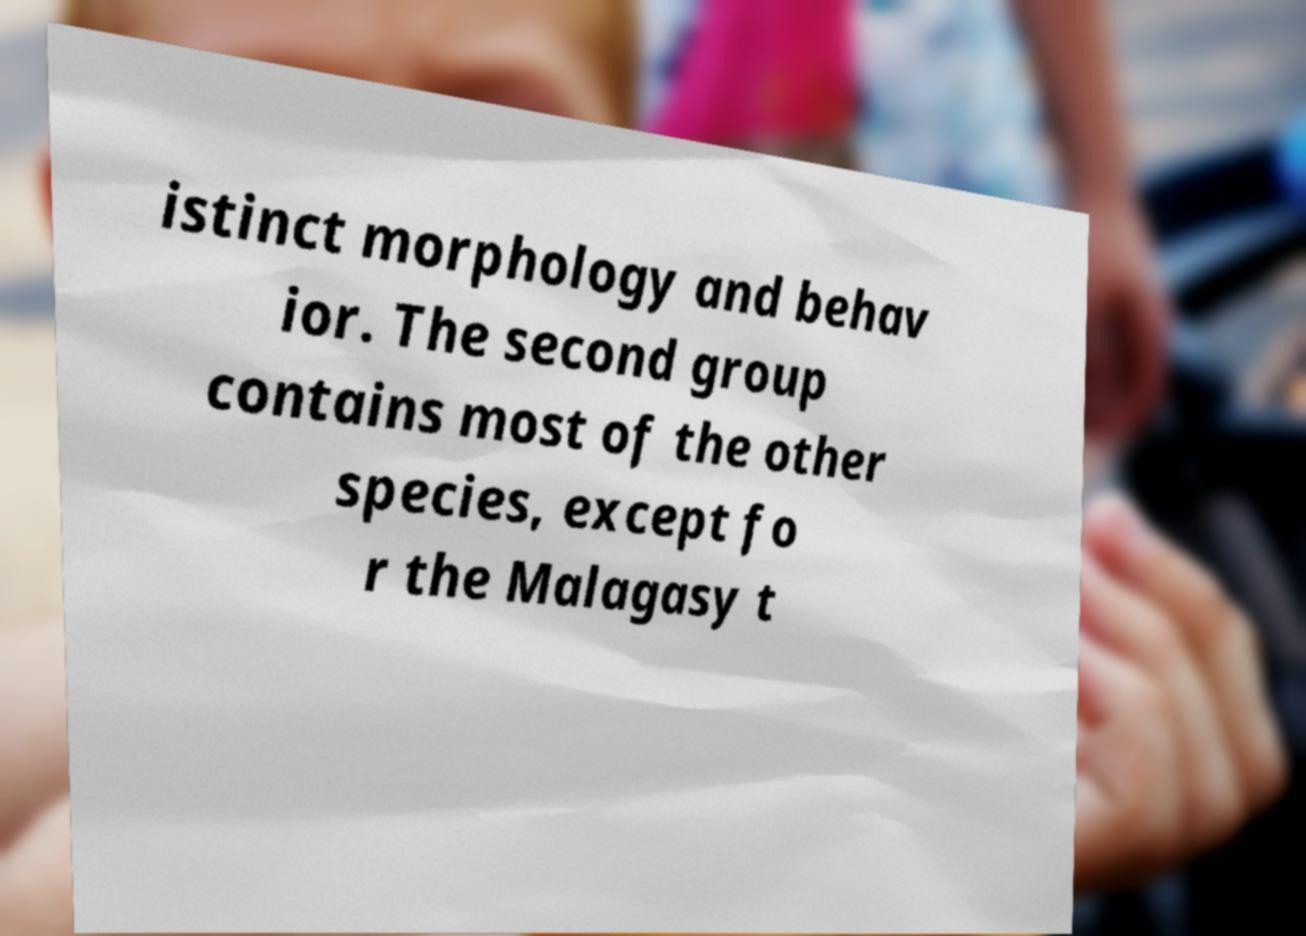For documentation purposes, I need the text within this image transcribed. Could you provide that? istinct morphology and behav ior. The second group contains most of the other species, except fo r the Malagasy t 